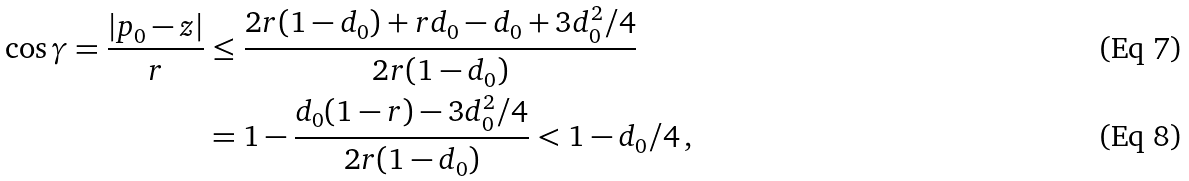Convert formula to latex. <formula><loc_0><loc_0><loc_500><loc_500>\cos \gamma = \frac { | p _ { 0 } - z | } { r } & \leq \frac { 2 r ( 1 - d _ { 0 } ) + r d _ { 0 } - d _ { 0 } + 3 d _ { 0 } ^ { 2 } / 4 } { 2 r ( 1 - d _ { 0 } ) } \\ & = 1 - \frac { d _ { 0 } ( 1 - r ) - 3 d _ { 0 } ^ { 2 } / 4 } { 2 r ( 1 - d _ { 0 } ) } < 1 - d _ { 0 } / 4 \, ,</formula> 